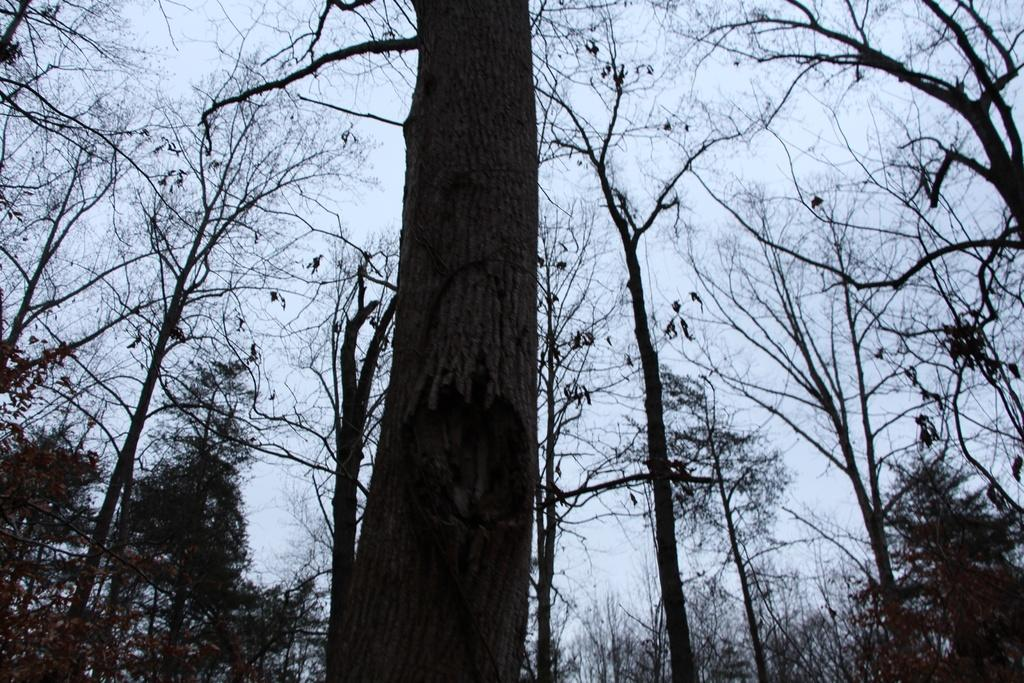What type of vegetation is visible on the ground in the image? There are trees on the ground in the image. What can be seen in the sky in the image? There are clouds in the sky in the image. How many lizards are crawling on the sponge in the image? There are no lizards or sponge present in the image. What type of breath can be seen coming from the trees in the image? Trees do not have the ability to breathe, so there is no breath visible in the image. 